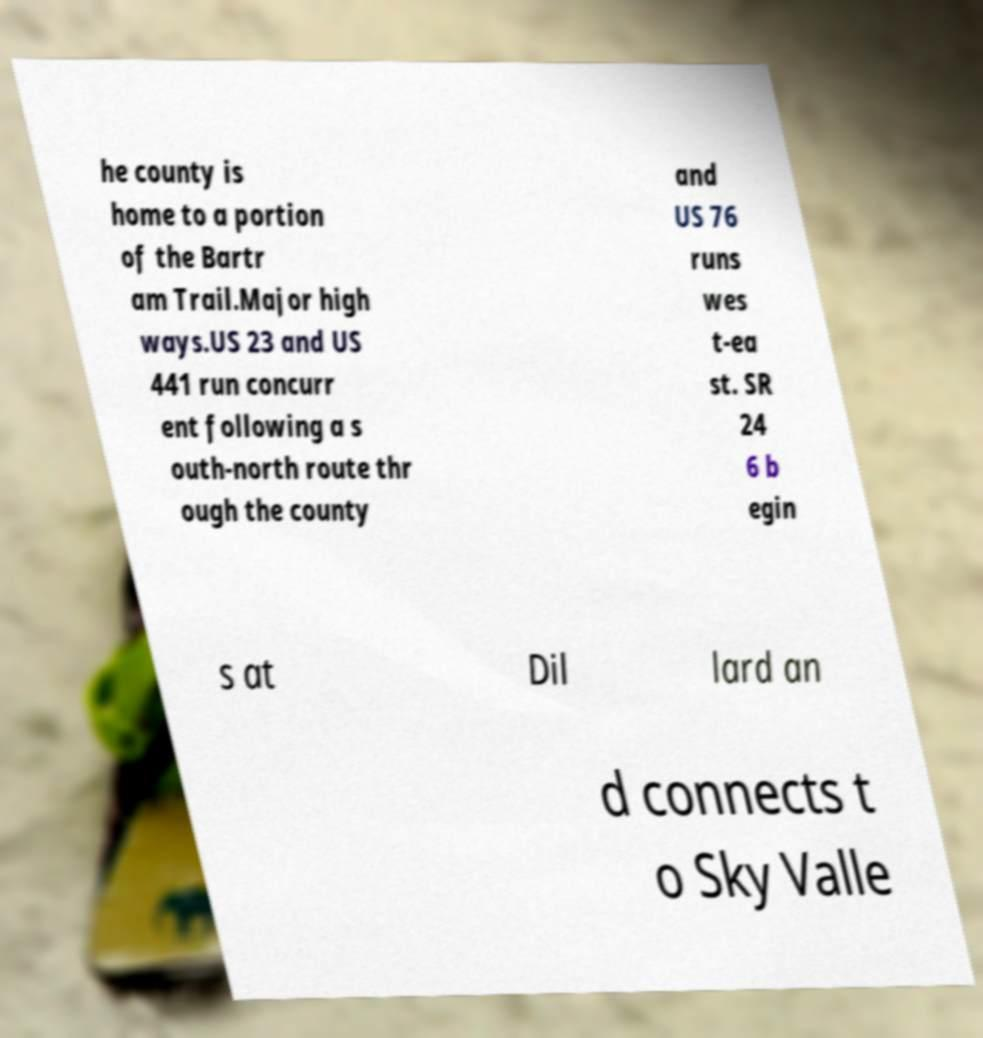For documentation purposes, I need the text within this image transcribed. Could you provide that? he county is home to a portion of the Bartr am Trail.Major high ways.US 23 and US 441 run concurr ent following a s outh-north route thr ough the county and US 76 runs wes t-ea st. SR 24 6 b egin s at Dil lard an d connects t o Sky Valle 